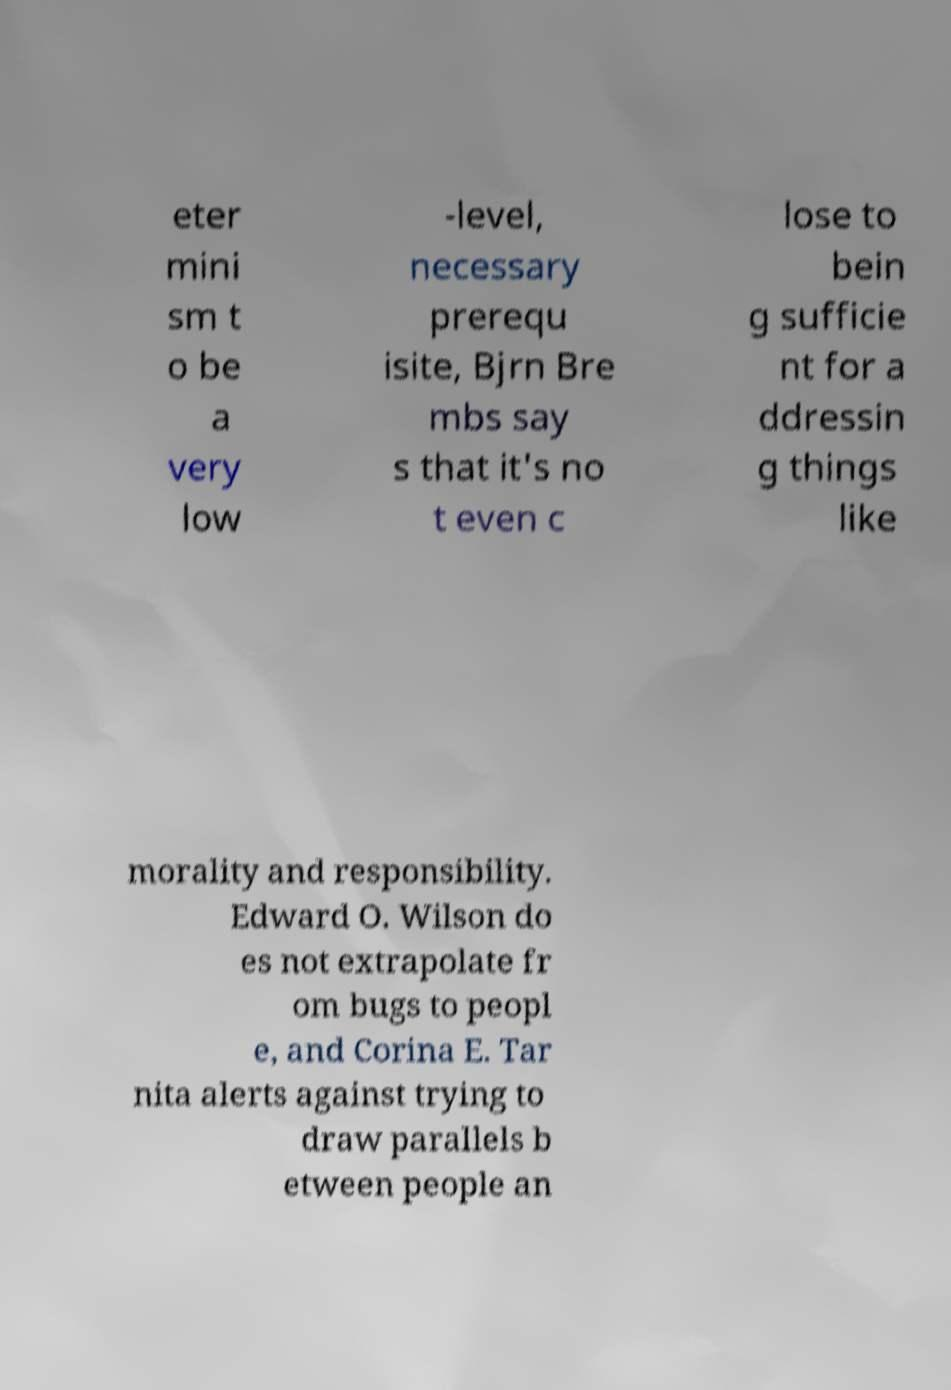What messages or text are displayed in this image? I need them in a readable, typed format. eter mini sm t o be a very low -level, necessary prerequ isite, Bjrn Bre mbs say s that it's no t even c lose to bein g sufficie nt for a ddressin g things like morality and responsibility. Edward O. Wilson do es not extrapolate fr om bugs to peopl e, and Corina E. Tar nita alerts against trying to draw parallels b etween people an 